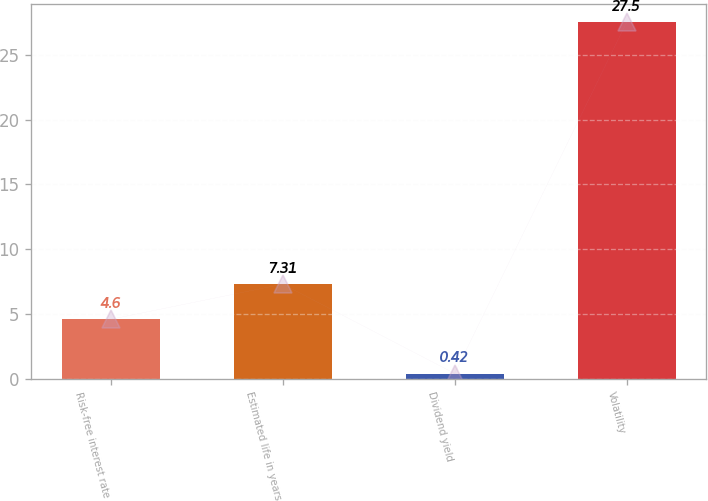<chart> <loc_0><loc_0><loc_500><loc_500><bar_chart><fcel>Risk-free interest rate<fcel>Estimated life in years<fcel>Dividend yield<fcel>Volatility<nl><fcel>4.6<fcel>7.31<fcel>0.42<fcel>27.5<nl></chart> 